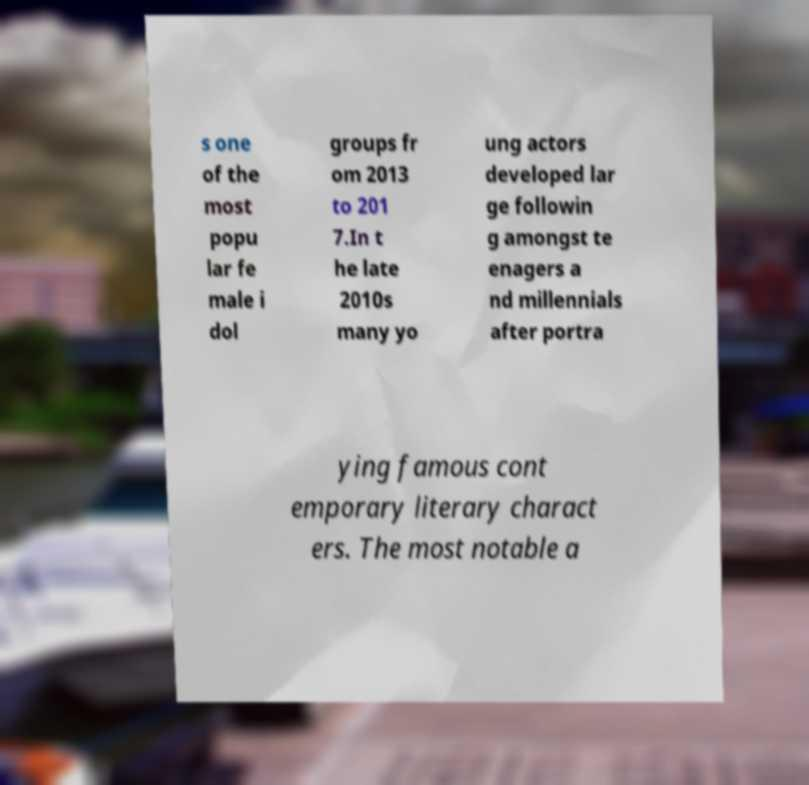Please read and relay the text visible in this image. What does it say? s one of the most popu lar fe male i dol groups fr om 2013 to 201 7.In t he late 2010s many yo ung actors developed lar ge followin g amongst te enagers a nd millennials after portra ying famous cont emporary literary charact ers. The most notable a 